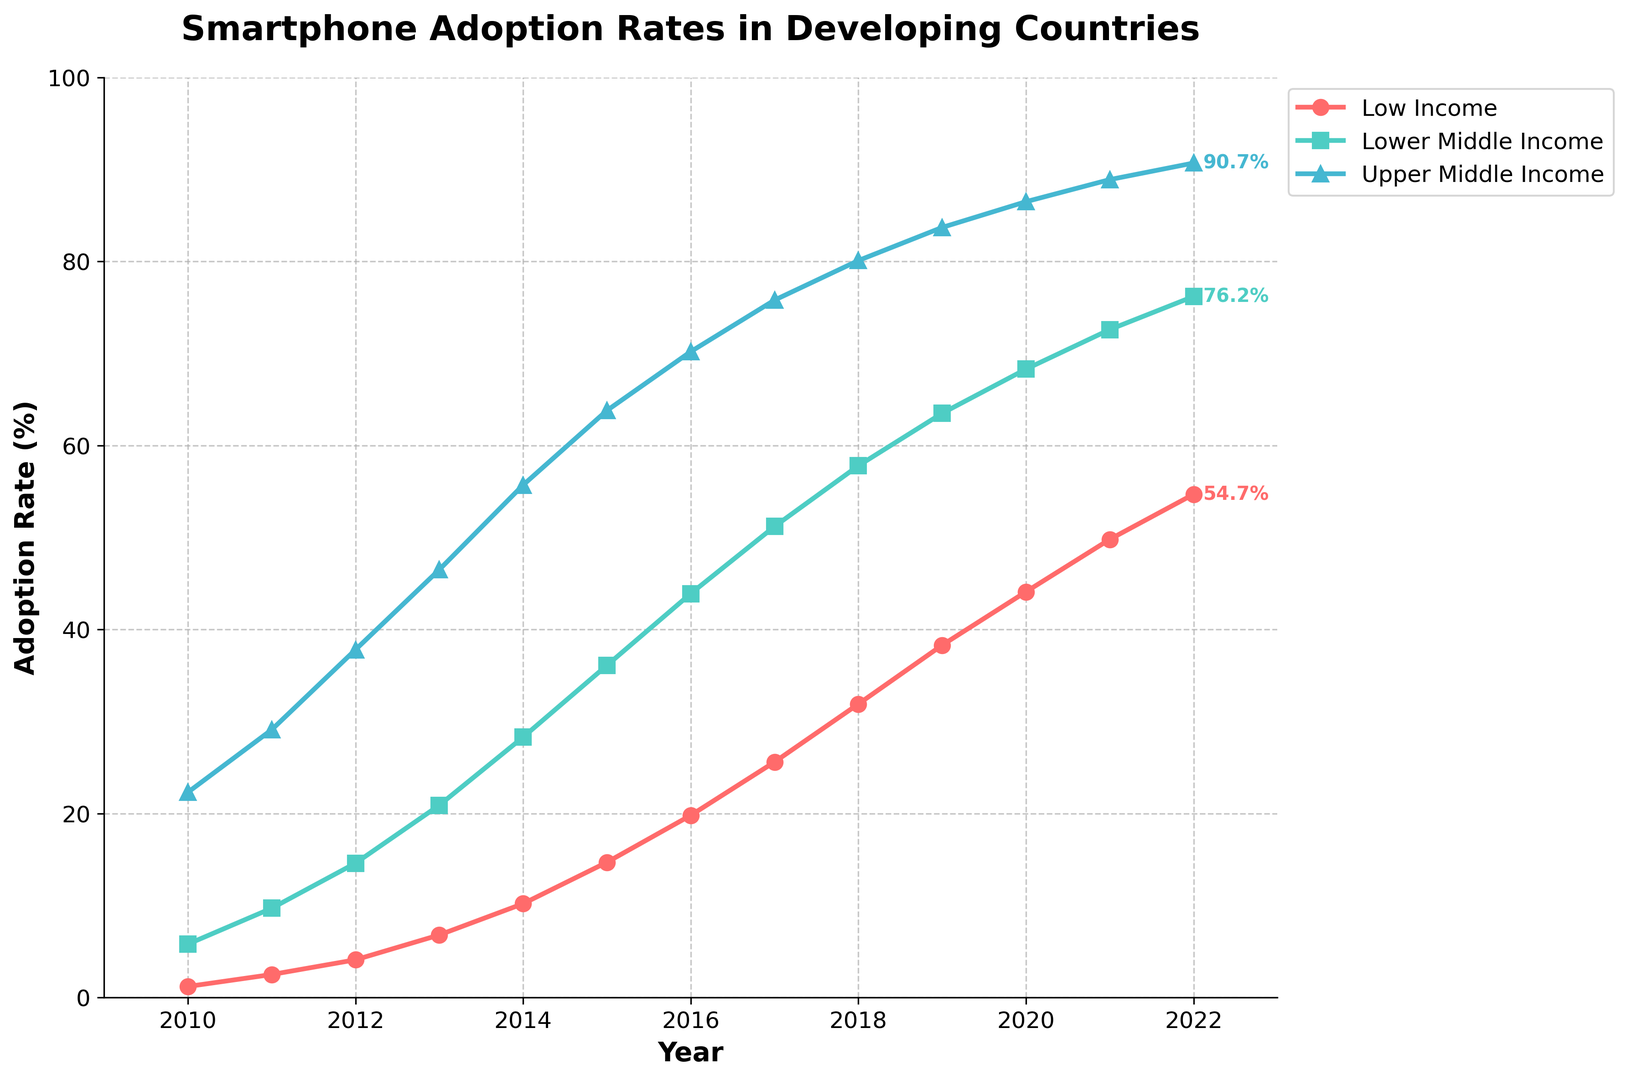What is the smartphone adoption rate for Upper Middle Income countries in 2022? Refer to the figure and find the line corresponding to Upper Middle Income countries. Locate the data point for the year 2022 and read the adoption rate from the y-axis.
Answer: 90.7% Between which years did Low Income countries see the highest increase in adoption rates? Analyze the slope of the line representing Low Income countries. The steepest slope indicates the highest increase. Comparing all segments, the steepest increase is observed between 2013 and 2014.
Answer: 2013-2014 What is the difference in smartphone adoption rates between Lower Middle Income and Upper Middle Income countries in 2016? Find the adoption rates for Lower Middle Income and Upper Middle Income countries in 2016. The rate for Lower Middle Income countries is 43.9%, and for Upper Middle Income, it is 70.2%. Subtract the Lower Middle Income rate from the Upper Middle Income rate: 70.2% - 43.9%.
Answer: 26.3% Which income category had the lowest adoption rate in 2010 and what was it? Look at the beginning of the lines representing different income categories for the year 2010. The lowest starting point is for the Low Income category, which is at 1.2%.
Answer: Low Income, 1.2% How many years did it take for all categories to exceed 50% adoption rates? For each category, find the year when the adoption rate first exceeds 50% by checking where each line crosses the 50% mark. For Low Income, it happens in 2022; for Lower Middle Income in 2018; and for Upper Middle Income in 2013. Calculate the number of years from 2010 to these respective years: 2022-2010, 2018-2010, and 2013-2010.
Answer: 12 years, 8 years, 3 years What is the average annual increase in adoption rates for Lower Middle Income countries from 2010 to 2022? Find the adoption rates for Lower Middle Income countries in 2010 (5.8%) and 2022 (76.2%). Subtract the 2010 rate from the 2022 rate to find the total increase (76.2% - 5.8% = 70.4%). Then, divide this value by the number of years (2022 - 2010 = 12) to get the average annual increase: 70.4% / 12.
Answer: 5.87% How does the adoption rate of Upper Middle Income countries in 2015 compare to that of Lower Middle Income countries in 2018? Find the adoption rate for Upper Middle Income countries in 2015, which is 63.8%, and for Lower Middle Income countries in 2018, which is 57.8%. Compare the two values to see that 63.8% is greater than 57.8%.
Answer: Upper Middle Income in 2015 has a higher rate During which period did Lower Middle Income countries see the smallest increase in smartphone adoption rates? Compare the changes in adoption rates between consecutive years for Lower Middle Income countries. The smallest increase is from 2010 to 2011, when the rate increases from 5.8% to 9.7%, a difference of 3.9%.
Answer: 2010-2011 What are the colors used to represent each income category? Examine the lines in the figure. The colors are: Low Income in red, Lower Middle Income in green, and Upper Middle Income in blue.
Answer: Red for Low Income, Green for Lower Middle Income, Blue for Upper Middle Income 